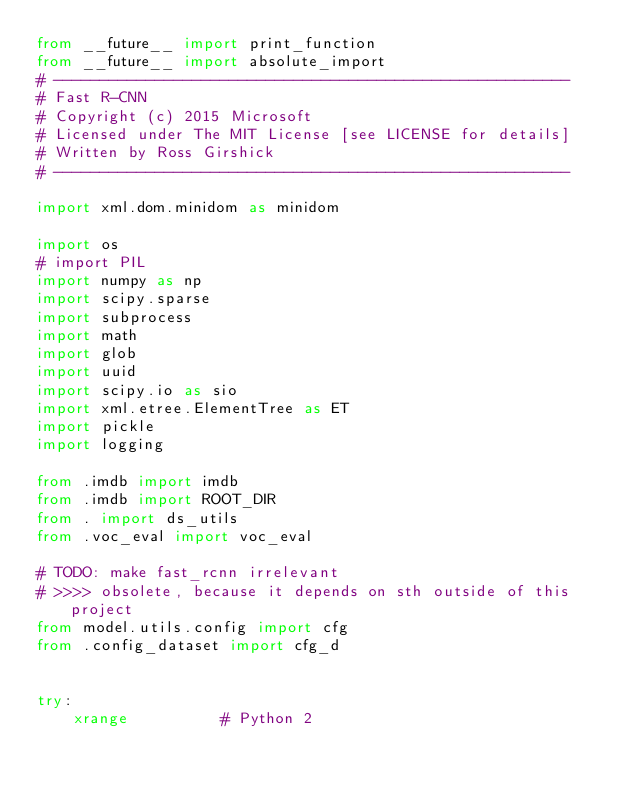<code> <loc_0><loc_0><loc_500><loc_500><_Python_>from __future__ import print_function
from __future__ import absolute_import
# --------------------------------------------------------
# Fast R-CNN
# Copyright (c) 2015 Microsoft
# Licensed under The MIT License [see LICENSE for details]
# Written by Ross Girshick
# --------------------------------------------------------

import xml.dom.minidom as minidom

import os
# import PIL
import numpy as np
import scipy.sparse
import subprocess
import math
import glob
import uuid
import scipy.io as sio
import xml.etree.ElementTree as ET
import pickle
import logging

from .imdb import imdb
from .imdb import ROOT_DIR
from . import ds_utils
from .voc_eval import voc_eval

# TODO: make fast_rcnn irrelevant
# >>>> obsolete, because it depends on sth outside of this project
from model.utils.config import cfg
from .config_dataset import cfg_d


try:
    xrange          # Python 2</code> 